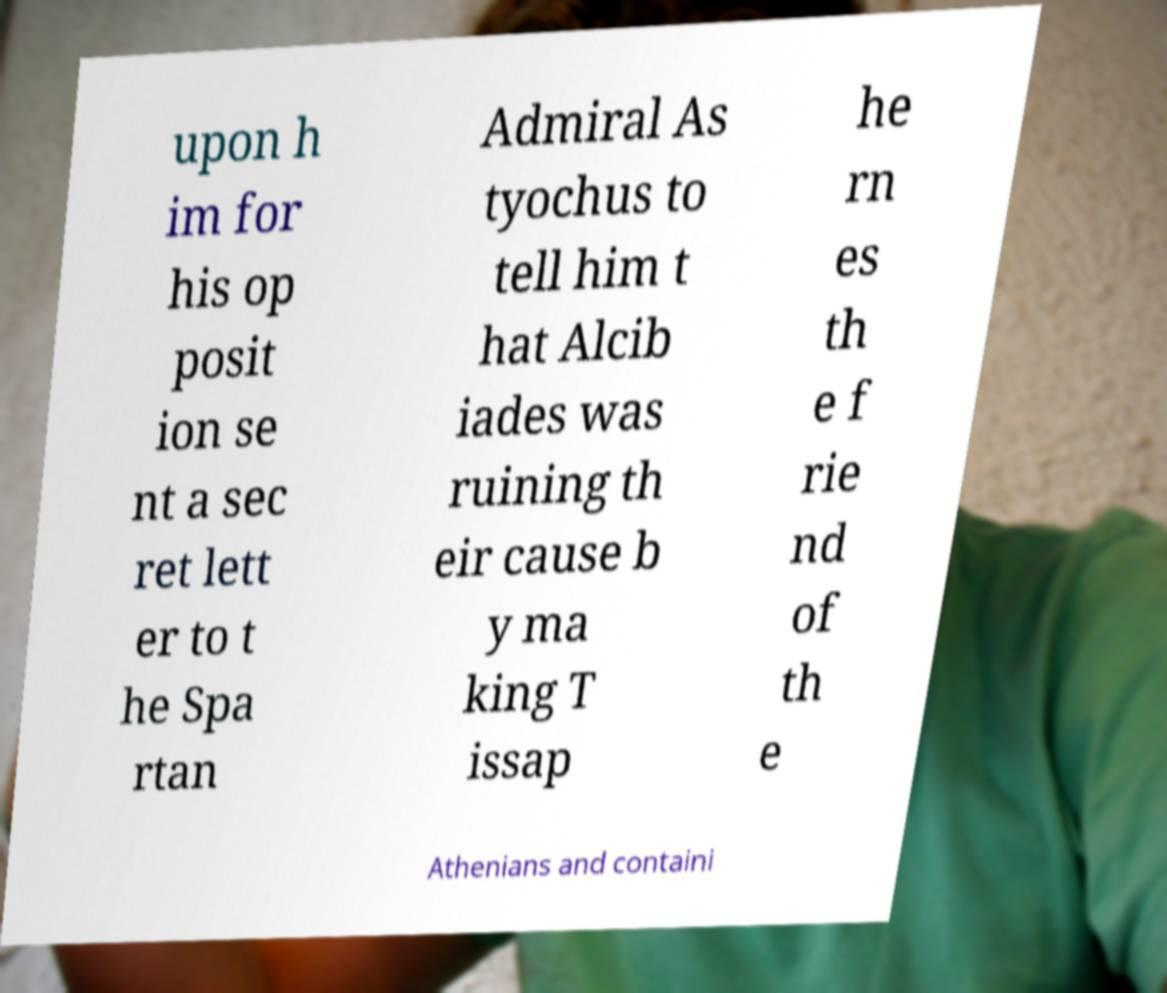Could you extract and type out the text from this image? upon h im for his op posit ion se nt a sec ret lett er to t he Spa rtan Admiral As tyochus to tell him t hat Alcib iades was ruining th eir cause b y ma king T issap he rn es th e f rie nd of th e Athenians and containi 